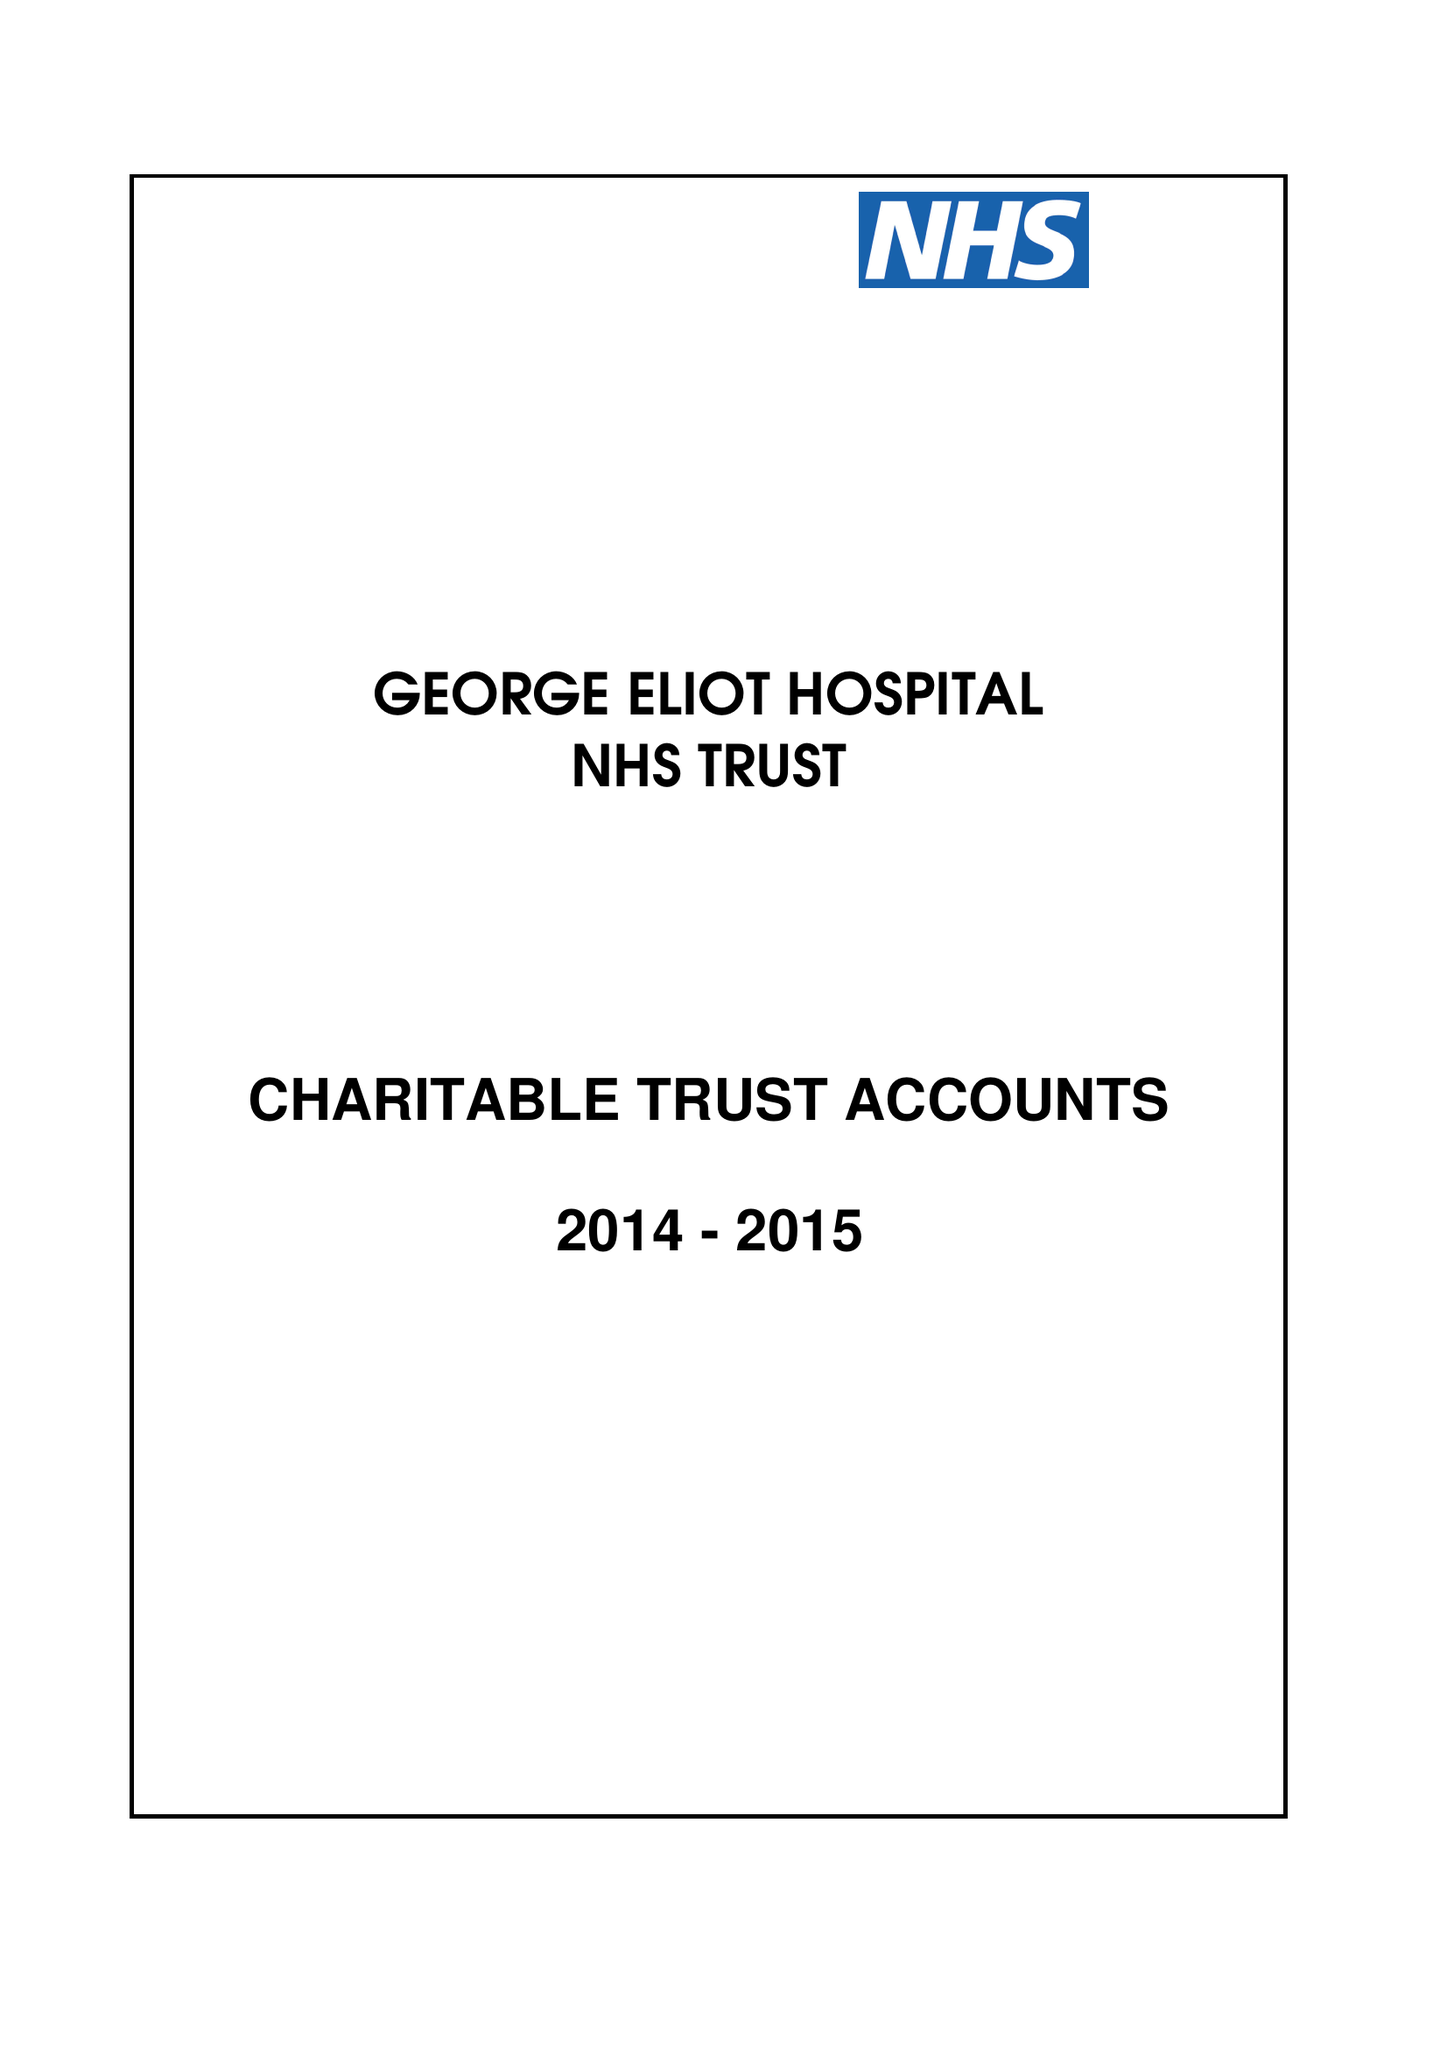What is the value for the income_annually_in_british_pounds?
Answer the question using a single word or phrase. 203000.00 